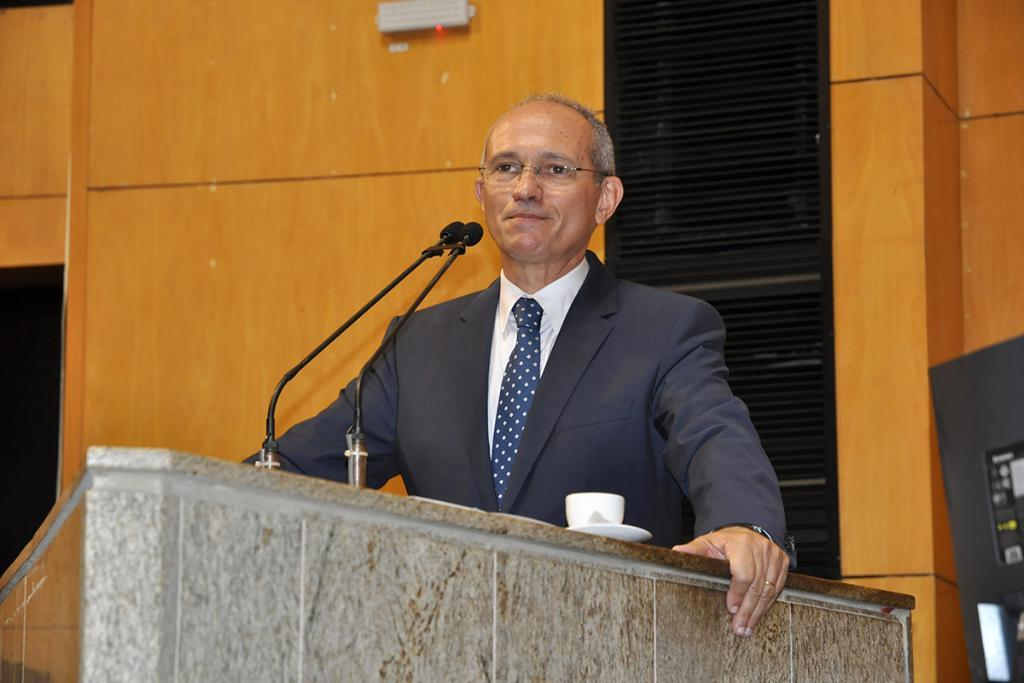What is the main subject of the image? There is a man in the image. What is the man standing next to? The man is standing next to a mic. What is the man wearing? The man is wearing a blazer and a blue tie. What other object can be seen in the image? There is a cup in the image. What is visible in the background of the image? There is a wall in the background of the image. How many beds are visible in the image? There are no beds present in the image. What type of expansion is the man performing in the image? The man is not performing any expansion in the image; he is simply standing next to a mic. 